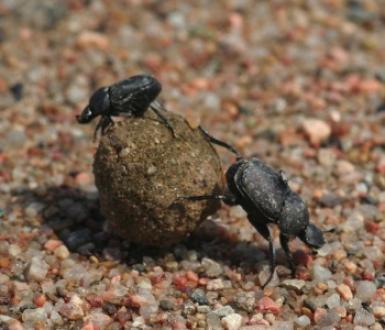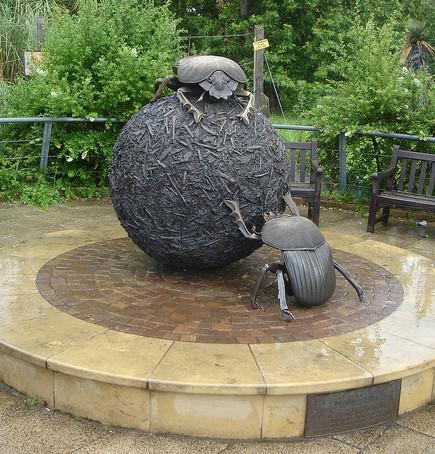The first image is the image on the left, the second image is the image on the right. For the images displayed, is the sentence "There are at most three beetles." factually correct? Answer yes or no. No. The first image is the image on the left, the second image is the image on the right. Evaluate the accuracy of this statement regarding the images: "One image contains a black beetle but no brown ball, and the other contains one brown ball and at least one beetle.". Is it true? Answer yes or no. No. 